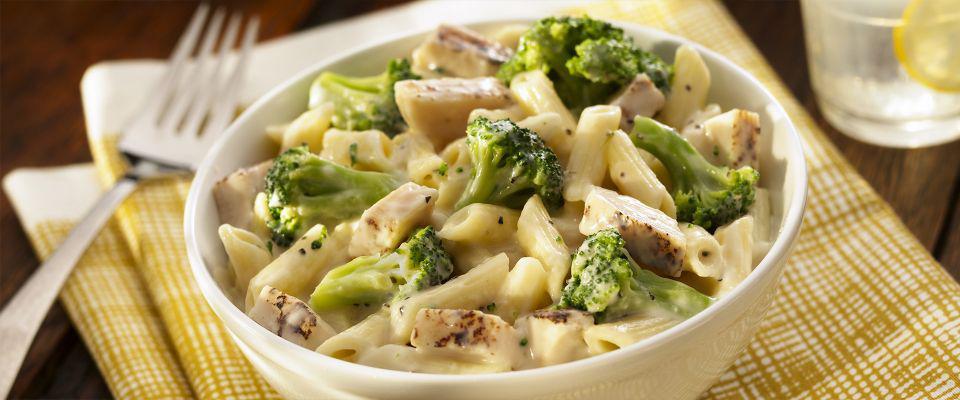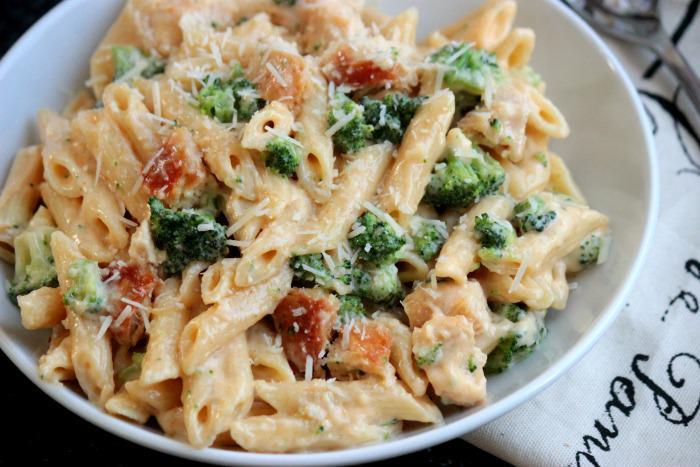The first image is the image on the left, the second image is the image on the right. Considering the images on both sides, is "One image shows a pasta dish served in a mahogany colored bowl." valid? Answer yes or no. No. 